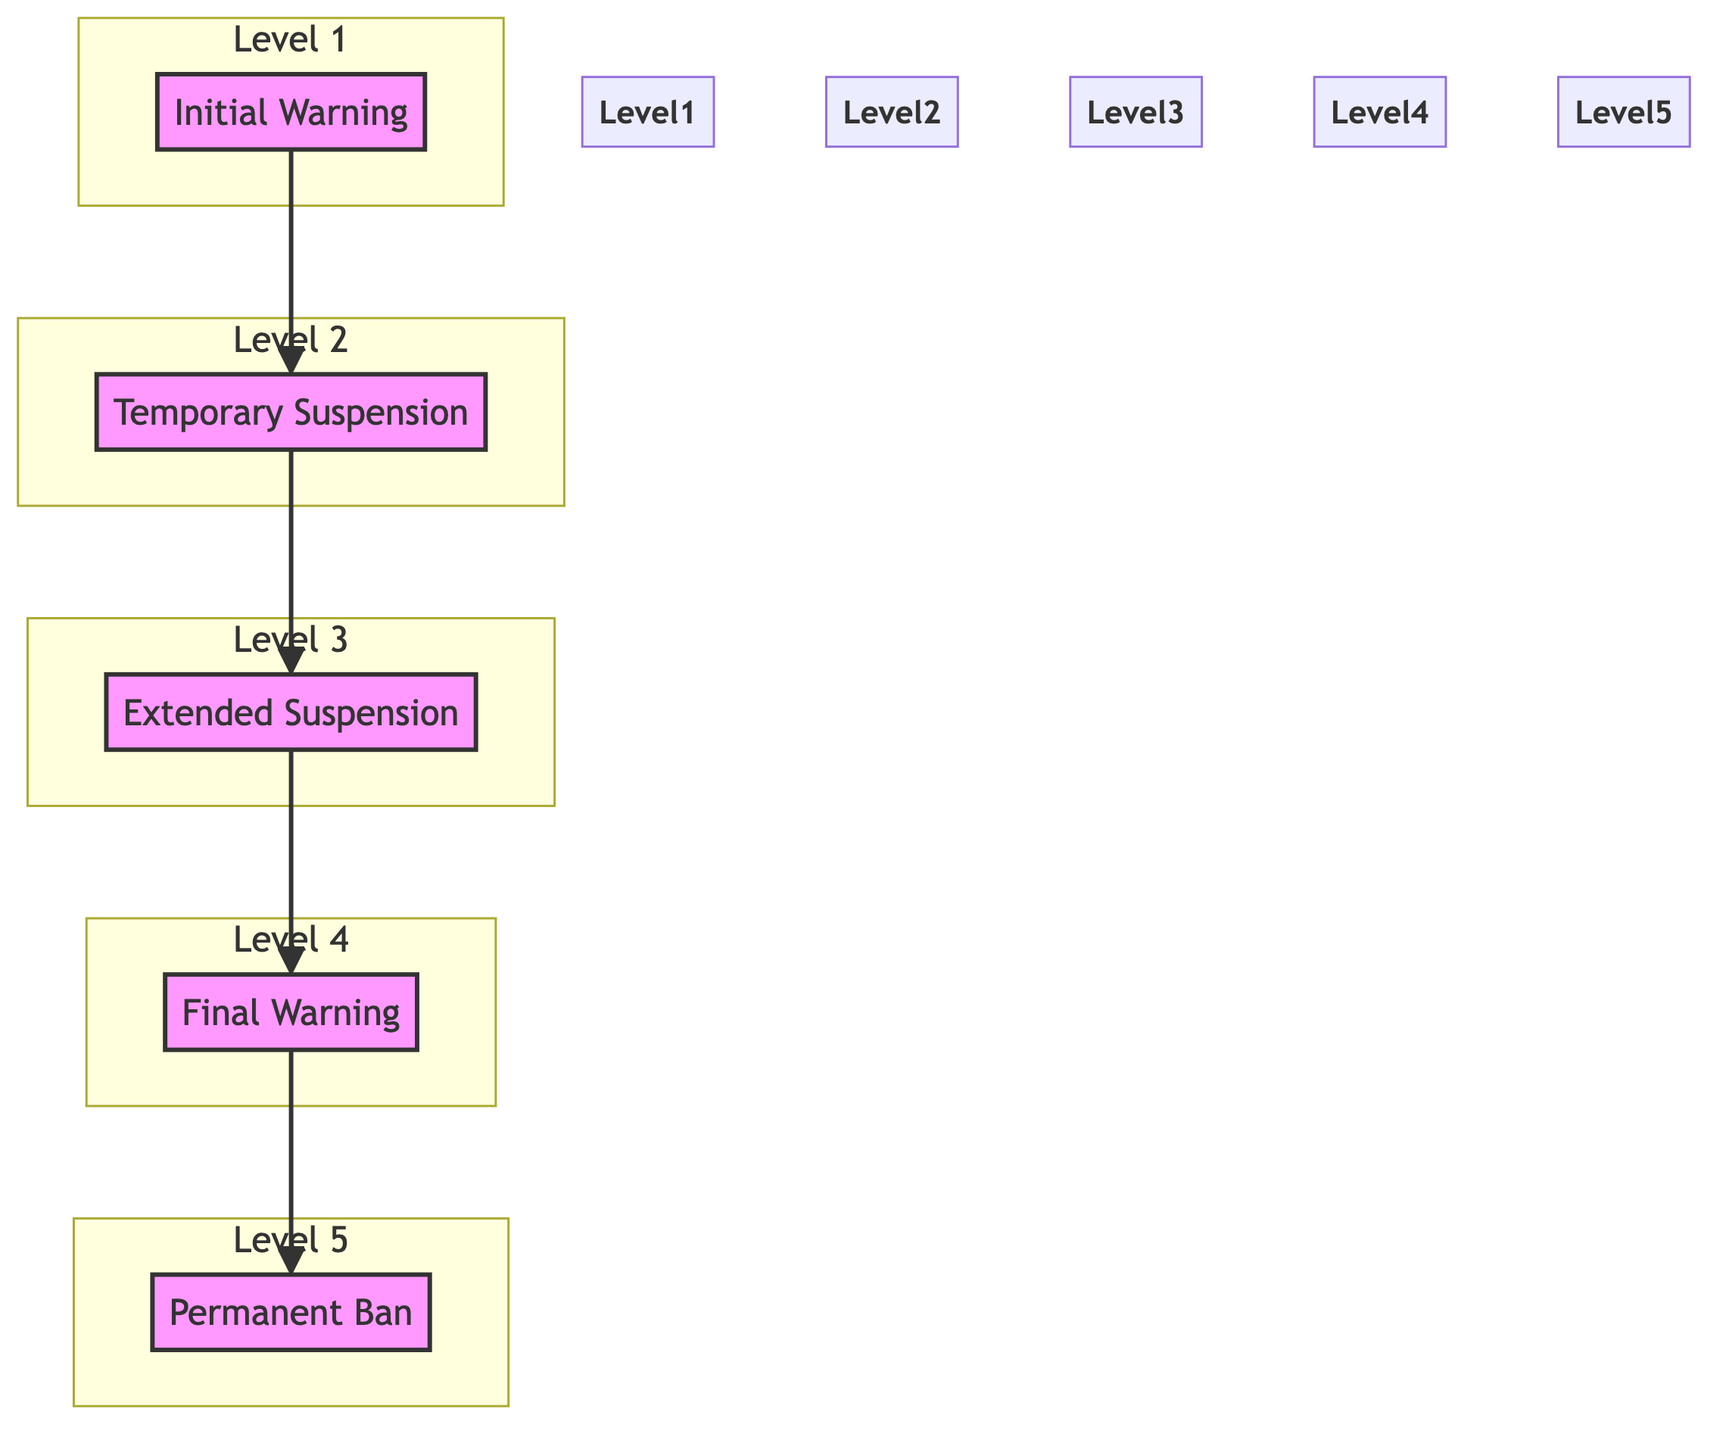What is the first step in the escalation process for policy violations? According to the diagram, the first step is "Initial Warning." This node is at the bottom of the flow chart, indicating it is the starting point.
Answer: Initial Warning How many levels are there in the escalation process? The diagram shows a total of five levels in the escalation process, each representing a step in handling policy violations.
Answer: 5 What follows after a Temporary Suspension? Based on the diagram, after a Temporary Suspension, the next step is the Extended Suspension. This indicates the progression in responses to escalating violations.
Answer: Extended Suspension Which step in the escalation process corresponds to a potential permanent ban? The "Final Warning" step correlates with the potential for a permanent ban, as it specifies that further violations will result in such an action.
Answer: Final Warning What is the last step in the escalation process? The last step in the process is "Permanent Ban," which signifies the final action taken against a user after multiple policy violations.
Answer: Permanent Ban How many steps must occur before reaching a Permanent Ban? To reach a Permanent Ban, there are four prior steps that must be followed: Initial Warning, Temporary Suspension, Extended Suspension, and Final Warning.
Answer: 4 What does the diagram represent in terms of communication to users? The diagram communicates a clear escalation protocol for handling policy violations, detailing the progression from warnings to potential banning.
Answer: Escalation protocol If a user receives an Extended Suspension, how many chances have they had before this step? If a user has reached the Extended Suspension step, it indicates they have already received two chances: the Initial Warning and Temporary Suspension, marking a pattern of violations.
Answer: 2 What is the purpose of the Final Warning step? The Final Warning serves as the last opportunity for the user to amend their behavior before facing a permanent ban from the forum.
Answer: Last opportunity 